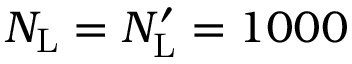<formula> <loc_0><loc_0><loc_500><loc_500>N _ { L } = N _ { L } ^ { \prime } = 1 0 0 0</formula> 